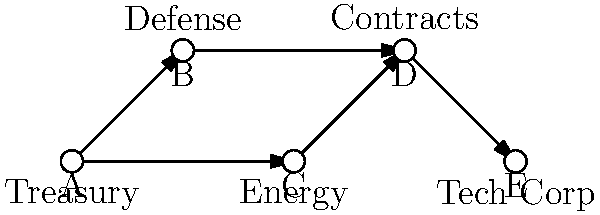In the network diagram above, departments A, B, C, and D represent government entities, while E represents a private technology corporation. Arrows indicate influence or information flow. Which department poses the highest risk for conflicts of interest, and why? To determine which department poses the highest risk for conflicts of interest, we need to analyze the network structure and information flow:

1. Department A (Treasury) has outgoing connections to B and C, but no incoming connections. It's influential but not directly at risk.

2. Department B (Defense) has an incoming connection from A and an outgoing connection to D. It has moderate risk due to its connection with Contracts (D).

3. Department C (Energy) has an incoming connection from A and an outgoing connection to D. It also has moderate risk due to its connection with Contracts (D).

4. Department D (Contracts) has incoming connections from B and C, and an outgoing connection to E (Tech Corp). This department poses the highest risk because:
   a. It receives information from two other government departments (Defense and Energy).
   b. It has a direct connection to the private sector (Tech Corp).
   c. It's responsible for contracts, which involve financial decisions and resource allocation.

5. E (Tech Corp) only has an incoming connection from D, representing the private sector's influence on government contracts.

Department D (Contracts) is the critical point where government information converges and then flows to the private sector. This position makes it the most susceptible to conflicts of interest, as it could potentially use information from Defense and Energy to favor Tech Corp in contract decisions.
Answer: Department D (Contracts) 